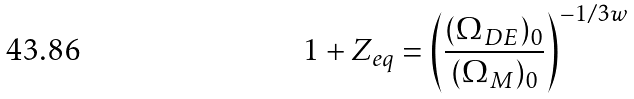Convert formula to latex. <formula><loc_0><loc_0><loc_500><loc_500>1 + Z _ { e q } = \left ( \frac { ( \Omega _ { D E } ) _ { 0 } } { ( \Omega _ { M } ) _ { 0 } } \right ) ^ { - 1 / 3 w }</formula> 